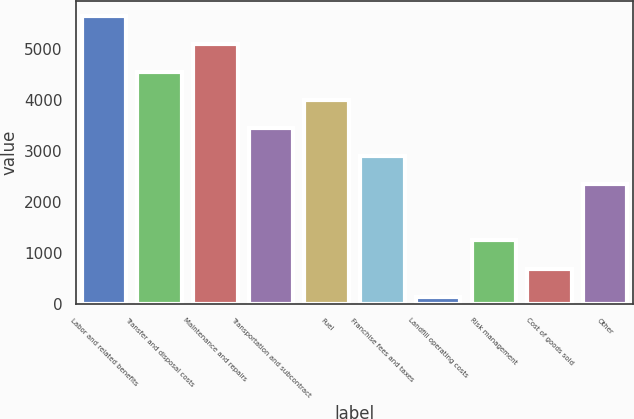Convert chart to OTSL. <chart><loc_0><loc_0><loc_500><loc_500><bar_chart><fcel>Labor and related benefits<fcel>Transfer and disposal costs<fcel>Maintenance and repairs<fcel>Transportation and subcontract<fcel>Fuel<fcel>Franchise fees and taxes<fcel>Landfill operating costs<fcel>Risk management<fcel>Cost of goods sold<fcel>Other<nl><fcel>5643.1<fcel>4543.5<fcel>5093.3<fcel>3443.9<fcel>3993.7<fcel>2894.1<fcel>145.1<fcel>1244.7<fcel>694.9<fcel>2344.3<nl></chart> 